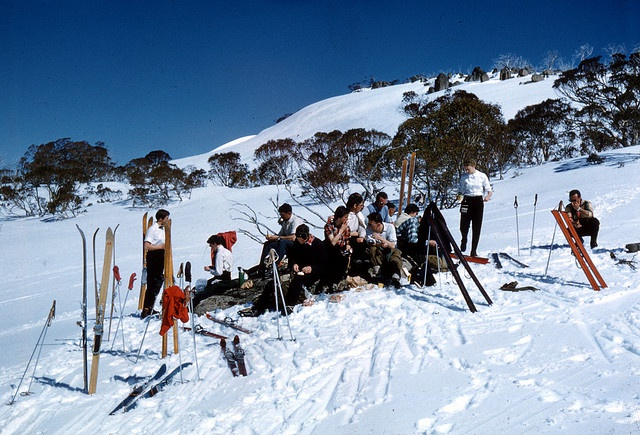Describe the objects in this image and their specific colors. I can see people in navy, black, gray, lavender, and darkgray tones, skis in navy, tan, gray, lavender, and darkgray tones, people in navy, black, lavender, gray, and darkgray tones, people in navy, black, gray, darkgray, and maroon tones, and people in navy, black, lavender, darkgray, and gray tones in this image. 